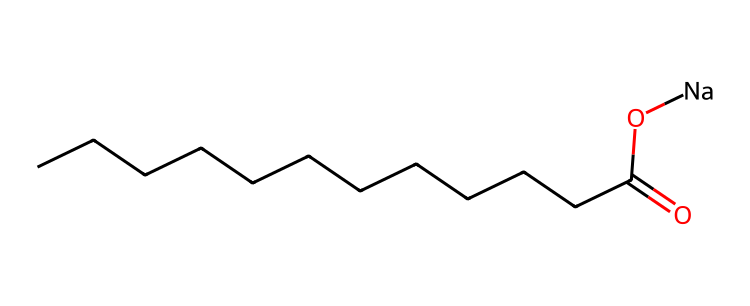What is the molecular formula of this detergent? To find the molecular formula, we identify the elements and their counts from the SMILES. The structure indicates carbon (C), hydrogen (H), and sodium (Na) atoms, with one carboxylic acid group. The carbon chain has 12 carbons, which gives C12, one carboxylic acid contribution makes it C12H25COO, and the sodium adds to giving Na. The final formula is C12H25NaO2.
Answer: C12H25NaO2 How many carbon atoms are present in the molecule? By analyzing the SMILES representation, each "C" indicates a carbon atom. Counting from the chain, there are 12 carbon atoms before the carboxylic group.
Answer: 12 What functional group is present in this detergent? The presence of the "C(=O)O" part of the structure indicates that it has a carboxylic acid functional group. This is due to the carbonyl (C=O) and hydroxyl (-OH) group connected to the terminal carbon.
Answer: carboxylic acid What role does sodium play in this detergent? Sodium (Na) is present as a counterion to the negatively charged carboxylate ion (from the carboxylic acid group when it ionizes). This ionic bond helps increase the solubility of the detergent in water, enhancing its cleaning ability.
Answer: counterion Does this detergent exhibit biodegradable properties? The presence of long carbon chains combined with a carboxylic acid functional group, which can readily break down in conditions of microbial activity, indicates it is biodegradable. The structural elements favor decomposition by microorganisms.
Answer: Yes 